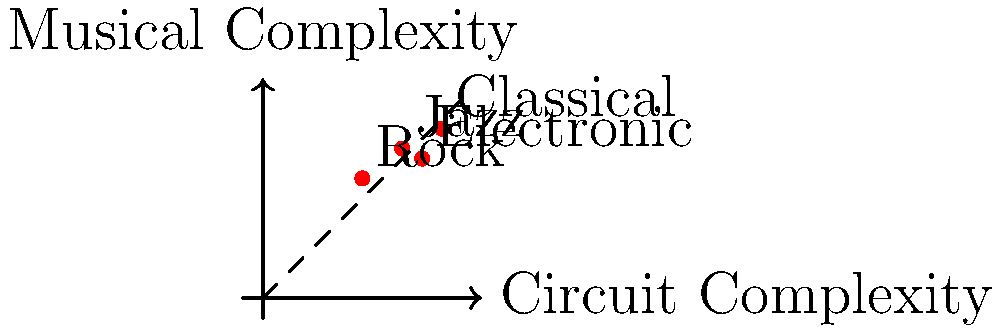As a visual artist collaborating with a DJ, you've created a graph correlating circuit diagram complexity with musical arrangement intricacy across different genres. Which genre shows the closest alignment between circuit complexity and musical intricacy, potentially suggesting a strong synergy between visual circuit art and the musical structure? To determine which genre shows the closest alignment between circuit complexity and musical intricacy, we need to analyze the plotted points for each genre:

1. Classical: Circuit complexity ≈ 0.9, Musical complexity ≈ 0.85
2. Jazz: Circuit complexity ≈ 0.7, Musical complexity ≈ 0.75
3. Rock: Circuit complexity ≈ 0.5, Musical complexity ≈ 0.6
4. Electronic: Circuit complexity ≈ 0.8, Musical complexity ≈ 0.7

The closest alignment would be represented by the point nearest to the dashed line, which indicates a perfect 1:1 correlation between circuit and musical complexity.

To determine this, we can calculate the difference between the two complexity values for each genre:

1. Classical: |0.9 - 0.85| = 0.05
2. Jazz: |0.7 - 0.75| = 0.05
3. Rock: |0.5 - 0.6| = 0.1
4. Electronic: |0.8 - 0.7| = 0.1

The smallest difference indicates the closest alignment. Both Classical and Jazz have a difference of 0.05, which is the smallest among all genres. However, Jazz is slightly closer to the dashed line visually, suggesting a marginally better alignment.
Answer: Jazz 